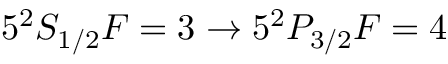Convert formula to latex. <formula><loc_0><loc_0><loc_500><loc_500>5 ^ { 2 } S _ { 1 / 2 } F = 3 \rightarrow 5 ^ { 2 } P _ { 3 / 2 } F = 4</formula> 